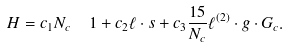<formula> <loc_0><loc_0><loc_500><loc_500>H = c _ { 1 } N _ { c } \ \ 1 + c _ { 2 } \ell \cdot s + c _ { 3 } \frac { 1 5 } { N _ { c } } \ell ^ { ( 2 ) } \cdot g \cdot G _ { c } .</formula> 